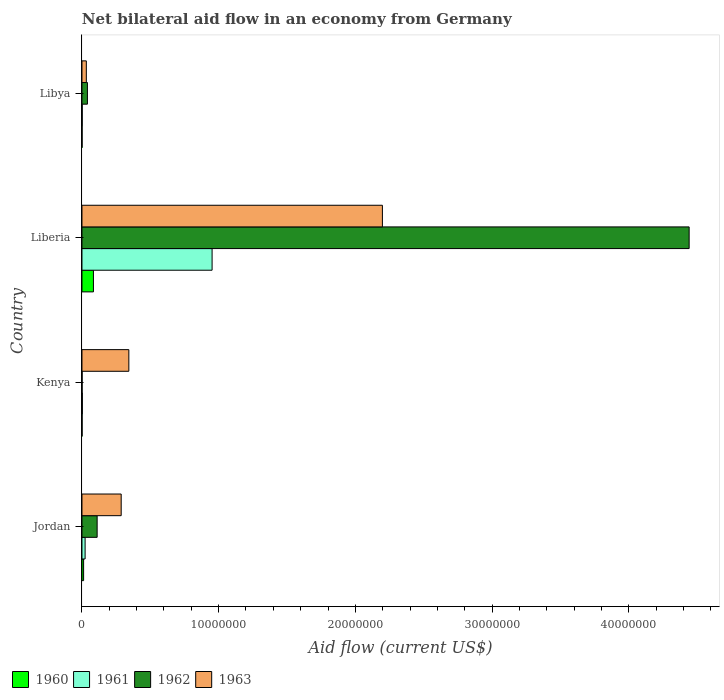How many different coloured bars are there?
Provide a short and direct response. 4. How many groups of bars are there?
Your answer should be very brief. 4. How many bars are there on the 3rd tick from the bottom?
Give a very brief answer. 4. What is the label of the 4th group of bars from the top?
Provide a short and direct response. Jordan. Across all countries, what is the maximum net bilateral aid flow in 1963?
Offer a very short reply. 2.20e+07. In which country was the net bilateral aid flow in 1961 maximum?
Your answer should be compact. Liberia. In which country was the net bilateral aid flow in 1962 minimum?
Give a very brief answer. Kenya. What is the total net bilateral aid flow in 1962 in the graph?
Keep it short and to the point. 4.59e+07. What is the difference between the net bilateral aid flow in 1960 in Kenya and that in Libya?
Keep it short and to the point. 0. What is the difference between the net bilateral aid flow in 1962 in Kenya and the net bilateral aid flow in 1960 in Liberia?
Provide a short and direct response. -8.30e+05. What is the average net bilateral aid flow in 1961 per country?
Give a very brief answer. 2.45e+06. What is the difference between the net bilateral aid flow in 1960 and net bilateral aid flow in 1962 in Kenya?
Ensure brevity in your answer.  0. In how many countries, is the net bilateral aid flow in 1961 greater than 28000000 US$?
Your answer should be very brief. 0. What is the ratio of the net bilateral aid flow in 1961 in Jordan to that in Kenya?
Offer a very short reply. 7.67. Is the net bilateral aid flow in 1962 in Liberia less than that in Libya?
Offer a very short reply. No. Is the difference between the net bilateral aid flow in 1960 in Liberia and Libya greater than the difference between the net bilateral aid flow in 1962 in Liberia and Libya?
Your answer should be very brief. No. What is the difference between the highest and the second highest net bilateral aid flow in 1962?
Offer a very short reply. 4.33e+07. What is the difference between the highest and the lowest net bilateral aid flow in 1960?
Make the answer very short. 8.30e+05. Is the sum of the net bilateral aid flow in 1960 in Jordan and Kenya greater than the maximum net bilateral aid flow in 1963 across all countries?
Ensure brevity in your answer.  No. What does the 2nd bar from the bottom in Jordan represents?
Give a very brief answer. 1961. How many bars are there?
Your response must be concise. 16. How many countries are there in the graph?
Ensure brevity in your answer.  4. What is the difference between two consecutive major ticks on the X-axis?
Offer a terse response. 1.00e+07. Are the values on the major ticks of X-axis written in scientific E-notation?
Your response must be concise. No. Where does the legend appear in the graph?
Give a very brief answer. Bottom left. How many legend labels are there?
Your answer should be compact. 4. How are the legend labels stacked?
Your answer should be very brief. Horizontal. What is the title of the graph?
Your answer should be very brief. Net bilateral aid flow in an economy from Germany. What is the label or title of the Y-axis?
Your answer should be compact. Country. What is the Aid flow (current US$) of 1962 in Jordan?
Offer a terse response. 1.11e+06. What is the Aid flow (current US$) of 1963 in Jordan?
Your answer should be very brief. 2.87e+06. What is the Aid flow (current US$) of 1960 in Kenya?
Ensure brevity in your answer.  10000. What is the Aid flow (current US$) in 1963 in Kenya?
Provide a succinct answer. 3.43e+06. What is the Aid flow (current US$) of 1960 in Liberia?
Your answer should be very brief. 8.40e+05. What is the Aid flow (current US$) in 1961 in Liberia?
Give a very brief answer. 9.52e+06. What is the Aid flow (current US$) in 1962 in Liberia?
Your response must be concise. 4.44e+07. What is the Aid flow (current US$) of 1963 in Liberia?
Provide a succinct answer. 2.20e+07. What is the Aid flow (current US$) in 1960 in Libya?
Provide a short and direct response. 10000. What is the Aid flow (current US$) in 1961 in Libya?
Provide a succinct answer. 2.00e+04. What is the Aid flow (current US$) of 1963 in Libya?
Provide a succinct answer. 3.20e+05. Across all countries, what is the maximum Aid flow (current US$) of 1960?
Ensure brevity in your answer.  8.40e+05. Across all countries, what is the maximum Aid flow (current US$) in 1961?
Your answer should be compact. 9.52e+06. Across all countries, what is the maximum Aid flow (current US$) in 1962?
Provide a short and direct response. 4.44e+07. Across all countries, what is the maximum Aid flow (current US$) of 1963?
Keep it short and to the point. 2.20e+07. Across all countries, what is the minimum Aid flow (current US$) in 1960?
Provide a short and direct response. 10000. Across all countries, what is the minimum Aid flow (current US$) of 1963?
Ensure brevity in your answer.  3.20e+05. What is the total Aid flow (current US$) of 1960 in the graph?
Give a very brief answer. 9.80e+05. What is the total Aid flow (current US$) in 1961 in the graph?
Your answer should be compact. 9.80e+06. What is the total Aid flow (current US$) in 1962 in the graph?
Make the answer very short. 4.59e+07. What is the total Aid flow (current US$) in 1963 in the graph?
Ensure brevity in your answer.  2.86e+07. What is the difference between the Aid flow (current US$) in 1960 in Jordan and that in Kenya?
Your answer should be very brief. 1.10e+05. What is the difference between the Aid flow (current US$) in 1961 in Jordan and that in Kenya?
Offer a terse response. 2.00e+05. What is the difference between the Aid flow (current US$) of 1962 in Jordan and that in Kenya?
Provide a succinct answer. 1.10e+06. What is the difference between the Aid flow (current US$) of 1963 in Jordan and that in Kenya?
Your answer should be very brief. -5.60e+05. What is the difference between the Aid flow (current US$) in 1960 in Jordan and that in Liberia?
Your answer should be compact. -7.20e+05. What is the difference between the Aid flow (current US$) of 1961 in Jordan and that in Liberia?
Provide a short and direct response. -9.29e+06. What is the difference between the Aid flow (current US$) in 1962 in Jordan and that in Liberia?
Provide a succinct answer. -4.33e+07. What is the difference between the Aid flow (current US$) in 1963 in Jordan and that in Liberia?
Make the answer very short. -1.91e+07. What is the difference between the Aid flow (current US$) in 1961 in Jordan and that in Libya?
Your answer should be compact. 2.10e+05. What is the difference between the Aid flow (current US$) in 1962 in Jordan and that in Libya?
Give a very brief answer. 7.10e+05. What is the difference between the Aid flow (current US$) in 1963 in Jordan and that in Libya?
Your response must be concise. 2.55e+06. What is the difference between the Aid flow (current US$) in 1960 in Kenya and that in Liberia?
Your answer should be very brief. -8.30e+05. What is the difference between the Aid flow (current US$) of 1961 in Kenya and that in Liberia?
Your response must be concise. -9.49e+06. What is the difference between the Aid flow (current US$) of 1962 in Kenya and that in Liberia?
Keep it short and to the point. -4.44e+07. What is the difference between the Aid flow (current US$) of 1963 in Kenya and that in Liberia?
Offer a terse response. -1.86e+07. What is the difference between the Aid flow (current US$) in 1960 in Kenya and that in Libya?
Make the answer very short. 0. What is the difference between the Aid flow (current US$) in 1962 in Kenya and that in Libya?
Ensure brevity in your answer.  -3.90e+05. What is the difference between the Aid flow (current US$) of 1963 in Kenya and that in Libya?
Give a very brief answer. 3.11e+06. What is the difference between the Aid flow (current US$) in 1960 in Liberia and that in Libya?
Ensure brevity in your answer.  8.30e+05. What is the difference between the Aid flow (current US$) in 1961 in Liberia and that in Libya?
Provide a succinct answer. 9.50e+06. What is the difference between the Aid flow (current US$) in 1962 in Liberia and that in Libya?
Your answer should be compact. 4.40e+07. What is the difference between the Aid flow (current US$) in 1963 in Liberia and that in Libya?
Your answer should be compact. 2.17e+07. What is the difference between the Aid flow (current US$) of 1960 in Jordan and the Aid flow (current US$) of 1962 in Kenya?
Provide a short and direct response. 1.10e+05. What is the difference between the Aid flow (current US$) of 1960 in Jordan and the Aid flow (current US$) of 1963 in Kenya?
Ensure brevity in your answer.  -3.31e+06. What is the difference between the Aid flow (current US$) of 1961 in Jordan and the Aid flow (current US$) of 1962 in Kenya?
Offer a very short reply. 2.20e+05. What is the difference between the Aid flow (current US$) in 1961 in Jordan and the Aid flow (current US$) in 1963 in Kenya?
Keep it short and to the point. -3.20e+06. What is the difference between the Aid flow (current US$) of 1962 in Jordan and the Aid flow (current US$) of 1963 in Kenya?
Give a very brief answer. -2.32e+06. What is the difference between the Aid flow (current US$) of 1960 in Jordan and the Aid flow (current US$) of 1961 in Liberia?
Offer a terse response. -9.40e+06. What is the difference between the Aid flow (current US$) of 1960 in Jordan and the Aid flow (current US$) of 1962 in Liberia?
Keep it short and to the point. -4.43e+07. What is the difference between the Aid flow (current US$) in 1960 in Jordan and the Aid flow (current US$) in 1963 in Liberia?
Provide a succinct answer. -2.19e+07. What is the difference between the Aid flow (current US$) of 1961 in Jordan and the Aid flow (current US$) of 1962 in Liberia?
Make the answer very short. -4.42e+07. What is the difference between the Aid flow (current US$) of 1961 in Jordan and the Aid flow (current US$) of 1963 in Liberia?
Provide a succinct answer. -2.18e+07. What is the difference between the Aid flow (current US$) in 1962 in Jordan and the Aid flow (current US$) in 1963 in Liberia?
Make the answer very short. -2.09e+07. What is the difference between the Aid flow (current US$) of 1960 in Jordan and the Aid flow (current US$) of 1962 in Libya?
Give a very brief answer. -2.80e+05. What is the difference between the Aid flow (current US$) in 1961 in Jordan and the Aid flow (current US$) in 1962 in Libya?
Offer a very short reply. -1.70e+05. What is the difference between the Aid flow (current US$) in 1962 in Jordan and the Aid flow (current US$) in 1963 in Libya?
Give a very brief answer. 7.90e+05. What is the difference between the Aid flow (current US$) of 1960 in Kenya and the Aid flow (current US$) of 1961 in Liberia?
Ensure brevity in your answer.  -9.51e+06. What is the difference between the Aid flow (current US$) of 1960 in Kenya and the Aid flow (current US$) of 1962 in Liberia?
Your answer should be compact. -4.44e+07. What is the difference between the Aid flow (current US$) in 1960 in Kenya and the Aid flow (current US$) in 1963 in Liberia?
Provide a succinct answer. -2.20e+07. What is the difference between the Aid flow (current US$) of 1961 in Kenya and the Aid flow (current US$) of 1962 in Liberia?
Your answer should be compact. -4.44e+07. What is the difference between the Aid flow (current US$) of 1961 in Kenya and the Aid flow (current US$) of 1963 in Liberia?
Ensure brevity in your answer.  -2.20e+07. What is the difference between the Aid flow (current US$) of 1962 in Kenya and the Aid flow (current US$) of 1963 in Liberia?
Offer a terse response. -2.20e+07. What is the difference between the Aid flow (current US$) in 1960 in Kenya and the Aid flow (current US$) in 1962 in Libya?
Provide a succinct answer. -3.90e+05. What is the difference between the Aid flow (current US$) in 1960 in Kenya and the Aid flow (current US$) in 1963 in Libya?
Your answer should be compact. -3.10e+05. What is the difference between the Aid flow (current US$) in 1961 in Kenya and the Aid flow (current US$) in 1962 in Libya?
Your response must be concise. -3.70e+05. What is the difference between the Aid flow (current US$) in 1962 in Kenya and the Aid flow (current US$) in 1963 in Libya?
Provide a short and direct response. -3.10e+05. What is the difference between the Aid flow (current US$) in 1960 in Liberia and the Aid flow (current US$) in 1961 in Libya?
Your response must be concise. 8.20e+05. What is the difference between the Aid flow (current US$) in 1960 in Liberia and the Aid flow (current US$) in 1963 in Libya?
Offer a very short reply. 5.20e+05. What is the difference between the Aid flow (current US$) in 1961 in Liberia and the Aid flow (current US$) in 1962 in Libya?
Offer a very short reply. 9.12e+06. What is the difference between the Aid flow (current US$) of 1961 in Liberia and the Aid flow (current US$) of 1963 in Libya?
Make the answer very short. 9.20e+06. What is the difference between the Aid flow (current US$) of 1962 in Liberia and the Aid flow (current US$) of 1963 in Libya?
Your response must be concise. 4.41e+07. What is the average Aid flow (current US$) of 1960 per country?
Your answer should be compact. 2.45e+05. What is the average Aid flow (current US$) of 1961 per country?
Keep it short and to the point. 2.45e+06. What is the average Aid flow (current US$) in 1962 per country?
Ensure brevity in your answer.  1.15e+07. What is the average Aid flow (current US$) of 1963 per country?
Give a very brief answer. 7.15e+06. What is the difference between the Aid flow (current US$) in 1960 and Aid flow (current US$) in 1962 in Jordan?
Provide a succinct answer. -9.90e+05. What is the difference between the Aid flow (current US$) of 1960 and Aid flow (current US$) of 1963 in Jordan?
Offer a very short reply. -2.75e+06. What is the difference between the Aid flow (current US$) in 1961 and Aid flow (current US$) in 1962 in Jordan?
Your answer should be compact. -8.80e+05. What is the difference between the Aid flow (current US$) in 1961 and Aid flow (current US$) in 1963 in Jordan?
Provide a succinct answer. -2.64e+06. What is the difference between the Aid flow (current US$) of 1962 and Aid flow (current US$) of 1963 in Jordan?
Provide a succinct answer. -1.76e+06. What is the difference between the Aid flow (current US$) of 1960 and Aid flow (current US$) of 1963 in Kenya?
Offer a very short reply. -3.42e+06. What is the difference between the Aid flow (current US$) in 1961 and Aid flow (current US$) in 1962 in Kenya?
Offer a very short reply. 2.00e+04. What is the difference between the Aid flow (current US$) in 1961 and Aid flow (current US$) in 1963 in Kenya?
Your response must be concise. -3.40e+06. What is the difference between the Aid flow (current US$) in 1962 and Aid flow (current US$) in 1963 in Kenya?
Provide a short and direct response. -3.42e+06. What is the difference between the Aid flow (current US$) in 1960 and Aid flow (current US$) in 1961 in Liberia?
Offer a very short reply. -8.68e+06. What is the difference between the Aid flow (current US$) of 1960 and Aid flow (current US$) of 1962 in Liberia?
Offer a terse response. -4.36e+07. What is the difference between the Aid flow (current US$) of 1960 and Aid flow (current US$) of 1963 in Liberia?
Your answer should be very brief. -2.11e+07. What is the difference between the Aid flow (current US$) of 1961 and Aid flow (current US$) of 1962 in Liberia?
Your answer should be very brief. -3.49e+07. What is the difference between the Aid flow (current US$) in 1961 and Aid flow (current US$) in 1963 in Liberia?
Offer a terse response. -1.25e+07. What is the difference between the Aid flow (current US$) of 1962 and Aid flow (current US$) of 1963 in Liberia?
Provide a short and direct response. 2.24e+07. What is the difference between the Aid flow (current US$) in 1960 and Aid flow (current US$) in 1962 in Libya?
Your response must be concise. -3.90e+05. What is the difference between the Aid flow (current US$) in 1960 and Aid flow (current US$) in 1963 in Libya?
Make the answer very short. -3.10e+05. What is the difference between the Aid flow (current US$) of 1961 and Aid flow (current US$) of 1962 in Libya?
Offer a terse response. -3.80e+05. What is the difference between the Aid flow (current US$) in 1961 and Aid flow (current US$) in 1963 in Libya?
Offer a very short reply. -3.00e+05. What is the ratio of the Aid flow (current US$) of 1960 in Jordan to that in Kenya?
Your answer should be very brief. 12. What is the ratio of the Aid flow (current US$) of 1961 in Jordan to that in Kenya?
Give a very brief answer. 7.67. What is the ratio of the Aid flow (current US$) of 1962 in Jordan to that in Kenya?
Keep it short and to the point. 111. What is the ratio of the Aid flow (current US$) in 1963 in Jordan to that in Kenya?
Your answer should be compact. 0.84. What is the ratio of the Aid flow (current US$) of 1960 in Jordan to that in Liberia?
Make the answer very short. 0.14. What is the ratio of the Aid flow (current US$) in 1961 in Jordan to that in Liberia?
Your answer should be very brief. 0.02. What is the ratio of the Aid flow (current US$) of 1962 in Jordan to that in Liberia?
Provide a short and direct response. 0.03. What is the ratio of the Aid flow (current US$) of 1963 in Jordan to that in Liberia?
Offer a very short reply. 0.13. What is the ratio of the Aid flow (current US$) in 1960 in Jordan to that in Libya?
Your answer should be very brief. 12. What is the ratio of the Aid flow (current US$) in 1962 in Jordan to that in Libya?
Give a very brief answer. 2.77. What is the ratio of the Aid flow (current US$) of 1963 in Jordan to that in Libya?
Your answer should be very brief. 8.97. What is the ratio of the Aid flow (current US$) of 1960 in Kenya to that in Liberia?
Ensure brevity in your answer.  0.01. What is the ratio of the Aid flow (current US$) in 1961 in Kenya to that in Liberia?
Your answer should be very brief. 0. What is the ratio of the Aid flow (current US$) of 1962 in Kenya to that in Liberia?
Your answer should be compact. 0. What is the ratio of the Aid flow (current US$) in 1963 in Kenya to that in Liberia?
Your answer should be compact. 0.16. What is the ratio of the Aid flow (current US$) of 1960 in Kenya to that in Libya?
Make the answer very short. 1. What is the ratio of the Aid flow (current US$) of 1962 in Kenya to that in Libya?
Offer a terse response. 0.03. What is the ratio of the Aid flow (current US$) of 1963 in Kenya to that in Libya?
Provide a succinct answer. 10.72. What is the ratio of the Aid flow (current US$) in 1961 in Liberia to that in Libya?
Give a very brief answer. 476. What is the ratio of the Aid flow (current US$) in 1962 in Liberia to that in Libya?
Provide a short and direct response. 111.05. What is the ratio of the Aid flow (current US$) of 1963 in Liberia to that in Libya?
Ensure brevity in your answer.  68.69. What is the difference between the highest and the second highest Aid flow (current US$) of 1960?
Your answer should be very brief. 7.20e+05. What is the difference between the highest and the second highest Aid flow (current US$) of 1961?
Offer a terse response. 9.29e+06. What is the difference between the highest and the second highest Aid flow (current US$) of 1962?
Your response must be concise. 4.33e+07. What is the difference between the highest and the second highest Aid flow (current US$) in 1963?
Offer a terse response. 1.86e+07. What is the difference between the highest and the lowest Aid flow (current US$) of 1960?
Make the answer very short. 8.30e+05. What is the difference between the highest and the lowest Aid flow (current US$) of 1961?
Keep it short and to the point. 9.50e+06. What is the difference between the highest and the lowest Aid flow (current US$) in 1962?
Your answer should be compact. 4.44e+07. What is the difference between the highest and the lowest Aid flow (current US$) of 1963?
Offer a terse response. 2.17e+07. 